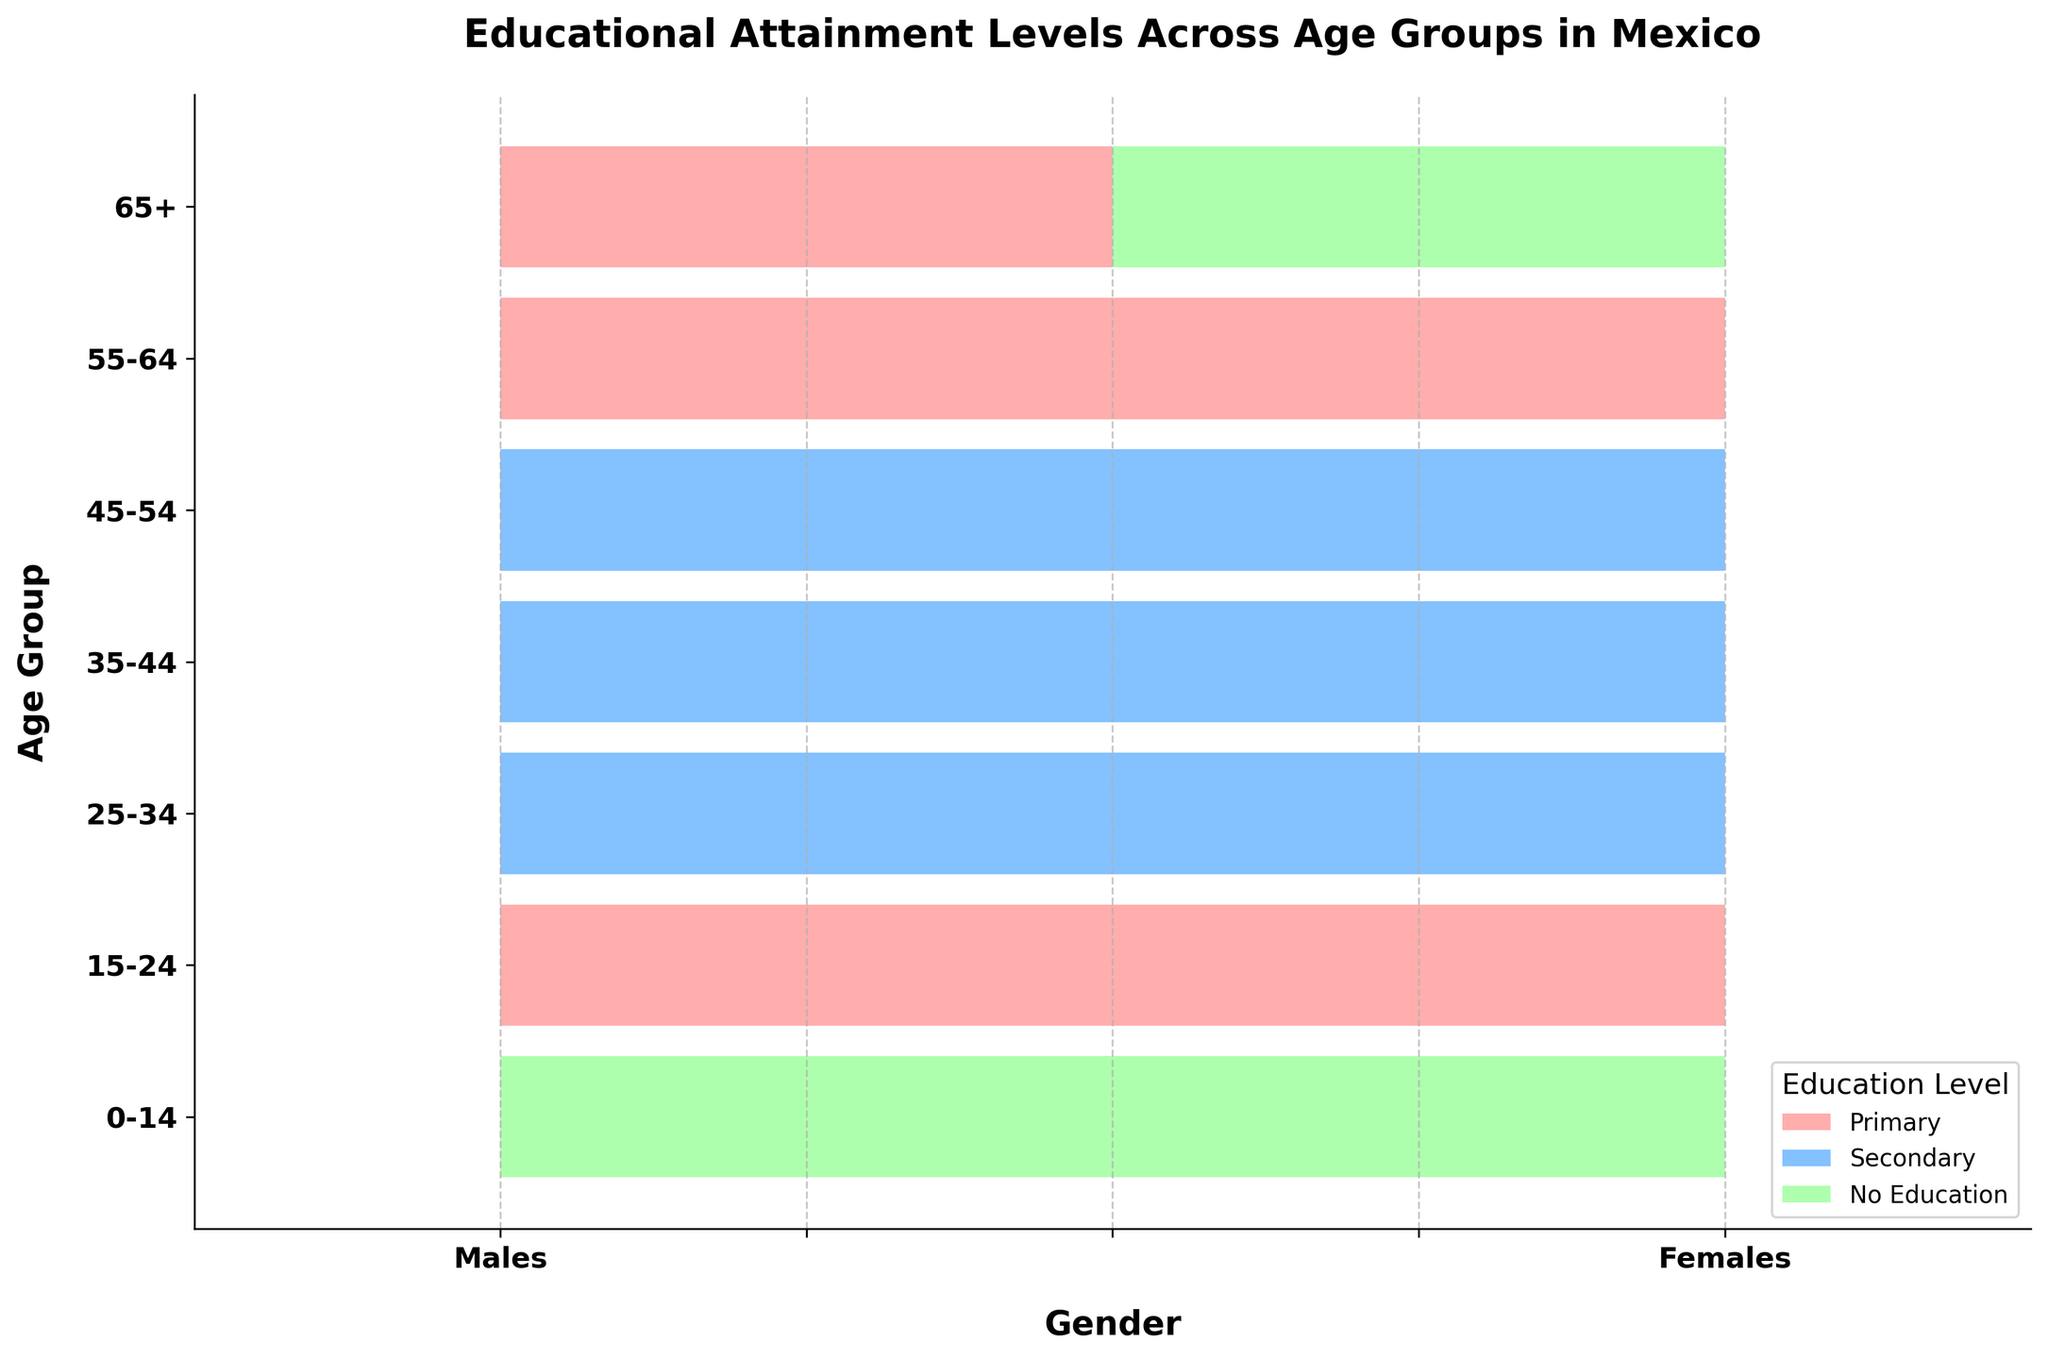What's the title of the figure? The title is written in bold at the top of the figure, which typically summarizes the main subject of the visualization.
Answer: Educational Attainment Levels Across Age Groups in Mexico What age group has the same educational level for both males and females? By inspecting the bars for both males and females side by side across age groups, you notice both genders have the same color, indicating the same level of education in the 15-24 and 55-64 age groups.
Answer: 15-24 and 55-64 What educational attainment level is most common in males aged 45-54? The bar for males aged 45-54 is colored based on the specified colors for different educational levels. The color is blue, indicating Secondary education.
Answer: Secondary Which gender has more individuals with no education in the age group 65+? By looking at the bars for both genders in the age group 65+, the females' bar shows green color (No Education) while males have pink (Primary), indicating females have more individuals with no education.
Answer: Females In which age group do females attain upper secondary education, but males do not? Compare the colors of the bars across age groups and observe that in the age group 35-44, females have a different color (blue) indicating Upper Secondary, while males have blue indicating Secondary.
Answer: 35-44 Calculate the average number of age groups where males have no education. Reviewing the bar colors for each age group and identifying the ones with green color for males, the age groups 0-14 and 65+ show green, tallying to 2 groups. The average is calculated as 2 / total age groups (7) = 0.29.
Answer: 0.29 What is the predominant educational level for females across all age groups? Summarize the educational levels indicated by the colors across different age groups for females; Primary education appears frequently (15-24, 55-64, 0-14 partially), indicating its predominance.
Answer: Primary Compare educational attainment in the age group 25-34 for both genders. Identify the colors for both males and females in this age group; both are blue, indicating that both have secondary education.
Answer: Secondary for both Which age group shows differing educational levels between genders? Examine each age group for differences in color between males and females. Age groups 35-44 and 65+ show different colors for males and females.
Answer: 35-44 and 65+ How many age groups show the same educational attainment for males and females? Check each age group's bars for consistency in color between males and females. The age groups 0-14, 15-24, and 55-64 show the same educational level for both genders.
Answer: 3 